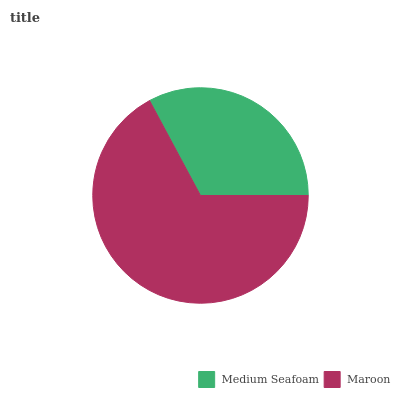Is Medium Seafoam the minimum?
Answer yes or no. Yes. Is Maroon the maximum?
Answer yes or no. Yes. Is Maroon the minimum?
Answer yes or no. No. Is Maroon greater than Medium Seafoam?
Answer yes or no. Yes. Is Medium Seafoam less than Maroon?
Answer yes or no. Yes. Is Medium Seafoam greater than Maroon?
Answer yes or no. No. Is Maroon less than Medium Seafoam?
Answer yes or no. No. Is Maroon the high median?
Answer yes or no. Yes. Is Medium Seafoam the low median?
Answer yes or no. Yes. Is Medium Seafoam the high median?
Answer yes or no. No. Is Maroon the low median?
Answer yes or no. No. 